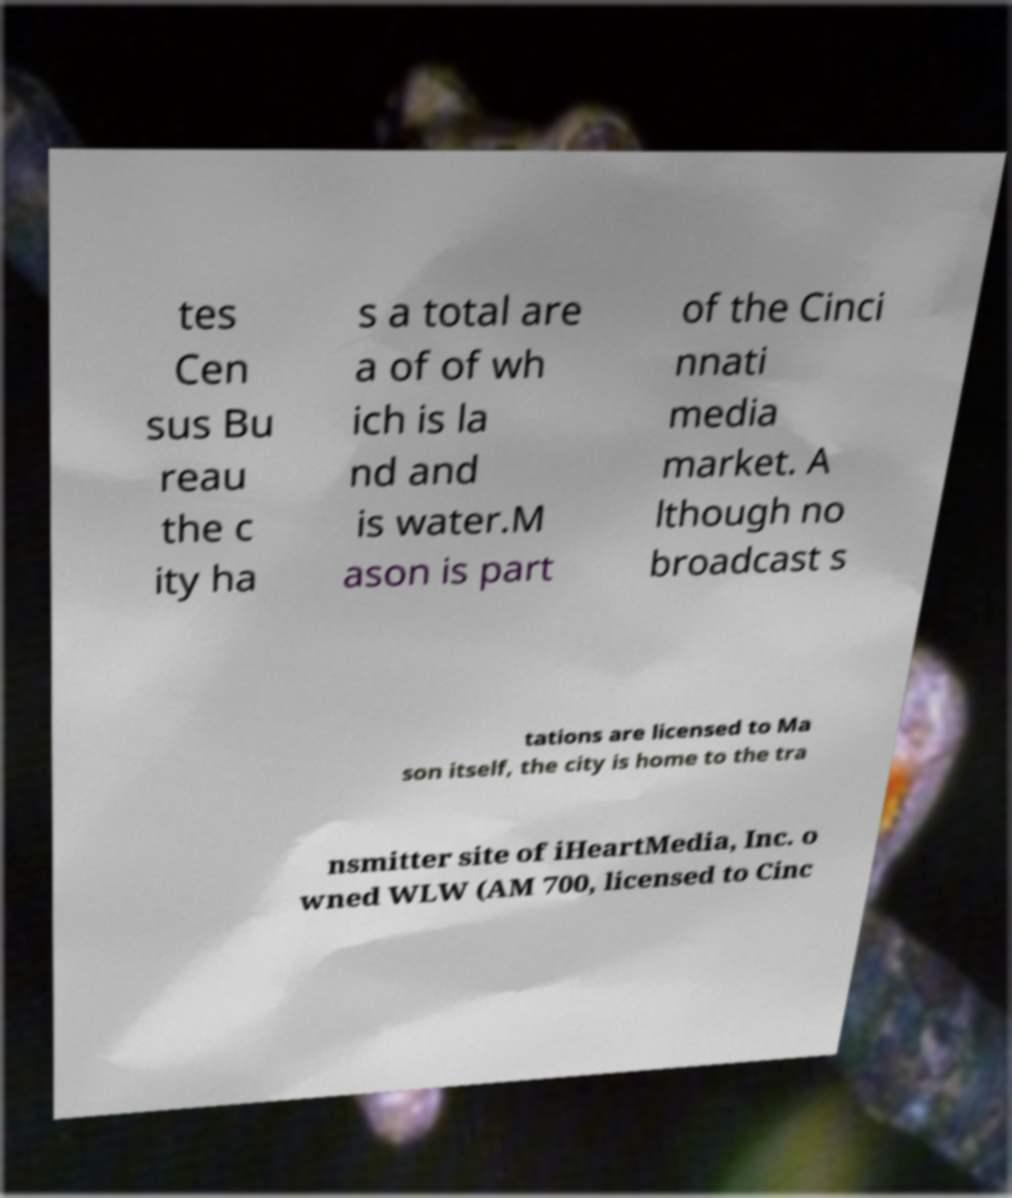What messages or text are displayed in this image? I need them in a readable, typed format. tes Cen sus Bu reau the c ity ha s a total are a of of wh ich is la nd and is water.M ason is part of the Cinci nnati media market. A lthough no broadcast s tations are licensed to Ma son itself, the city is home to the tra nsmitter site of iHeartMedia, Inc. o wned WLW (AM 700, licensed to Cinc 